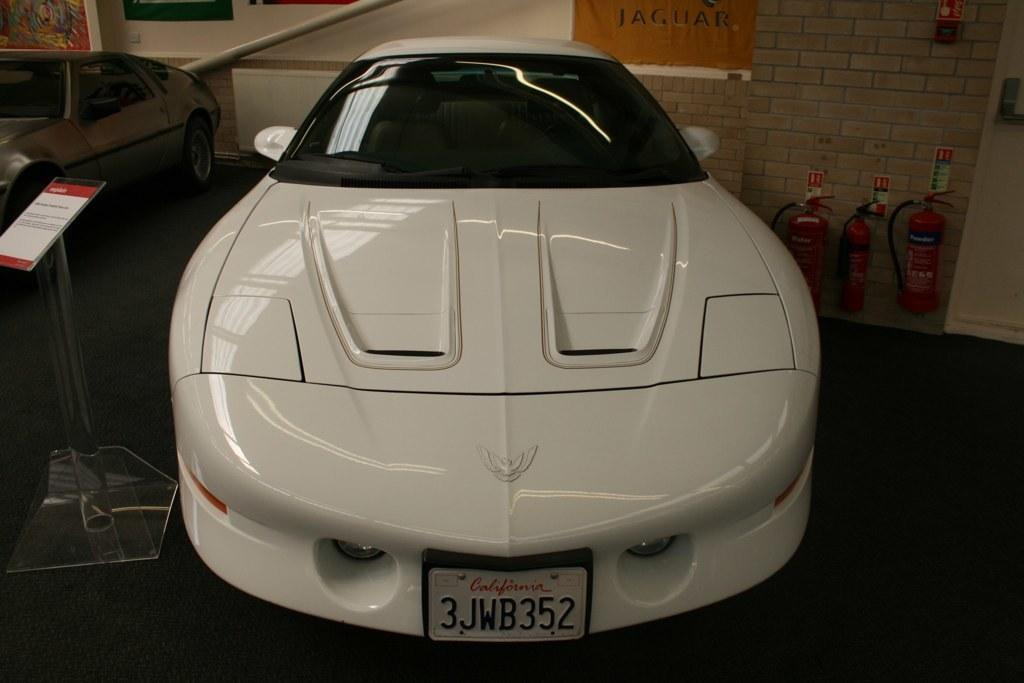What type of vehicles can be seen in the image? There are cars in the image. Can you describe the location of the white car in the image? The white car is in the middle of the image. Does the white car have any distinguishing features? Yes, the white car has a number plate. What type of whip is being used to control the pig in the image? There is no whip or pig present in the image; it features cars. 